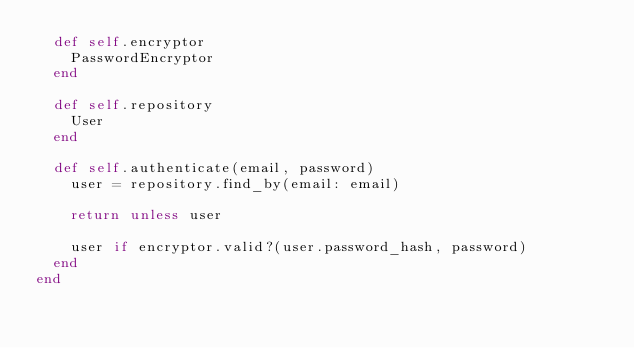Convert code to text. <code><loc_0><loc_0><loc_500><loc_500><_Ruby_>  def self.encryptor
    PasswordEncryptor
  end

  def self.repository
    User
  end

  def self.authenticate(email, password)
    user = repository.find_by(email: email)

    return unless user

    user if encryptor.valid?(user.password_hash, password)
  end
end
</code> 